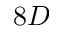Convert formula to latex. <formula><loc_0><loc_0><loc_500><loc_500>8 D</formula> 